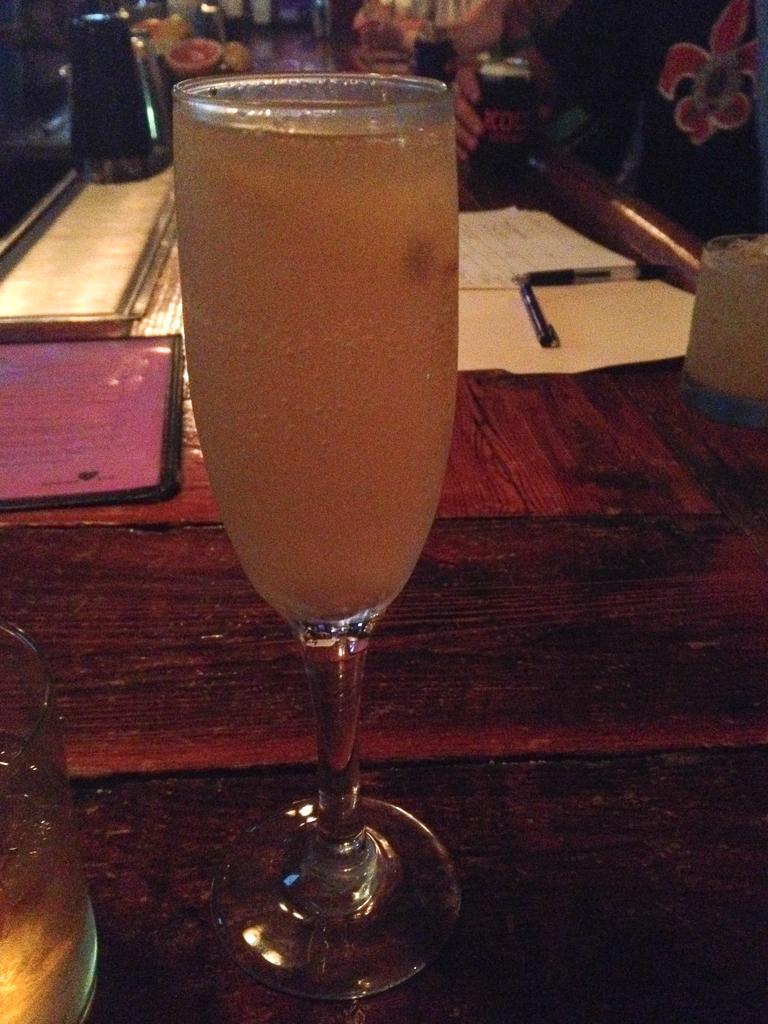Could you give a brief overview of what you see in this image? In this image we can see one table, some objects are on the surface and different kinds of objects are on the table. One person is standing and holding one object. 